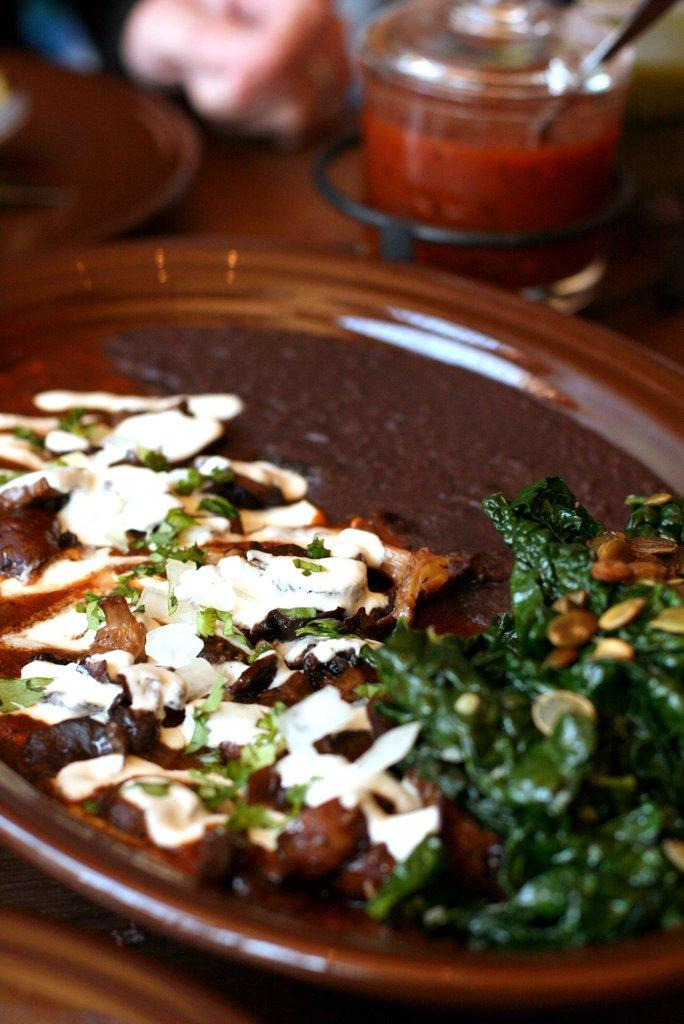What is on the tray that is visible in the image? There is a tray with food items in the image. What else can be seen in the background of the image? There is a container in the background of the image. What is inside the container? There is an item inside the container. How would you describe the background of the image? The background is blurry. Is there a crown visible on the tray in the image? No, there is no crown visible on the tray in the image. 